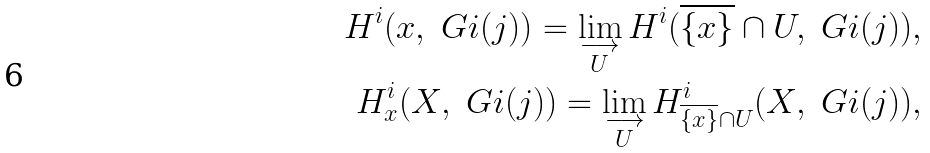<formula> <loc_0><loc_0><loc_500><loc_500>H ^ { i } ( x , \ G i ( j ) ) = \lim _ { \substack { \longrightarrow \\ U } } H ^ { i } ( \overline { \{ x \} } \cap U , \ G i ( j ) ) , \\ H ^ { i } _ { x } ( X , \ G i ( j ) ) = \lim _ { \substack { \longrightarrow \\ U } } H ^ { i } _ { \overline { \{ x \} } \cap U } ( X , \ G i ( j ) ) ,</formula> 